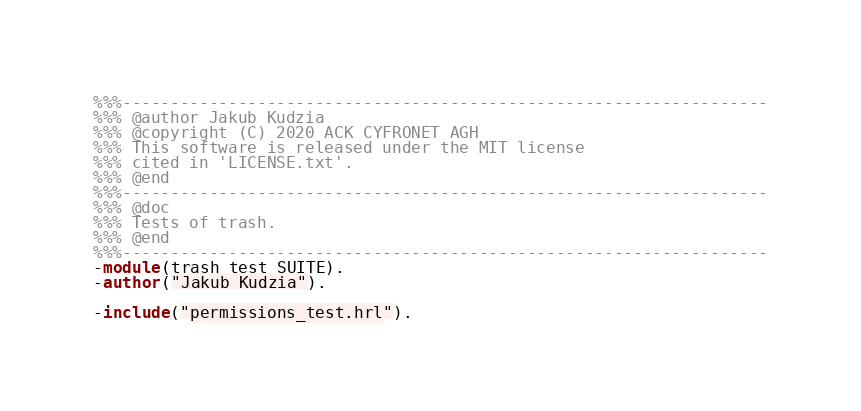<code> <loc_0><loc_0><loc_500><loc_500><_Erlang_>%%%-------------------------------------------------------------------
%%% @author Jakub Kudzia
%%% @copyright (C) 2020 ACK CYFRONET AGH
%%% This software is released under the MIT license
%%% cited in 'LICENSE.txt'.
%%% @end
%%%-------------------------------------------------------------------
%%% @doc
%%% Tests of trash.
%%% @end
%%%-------------------------------------------------------------------
-module(trash_test_SUITE).
-author("Jakub Kudzia").

-include("permissions_test.hrl").</code> 